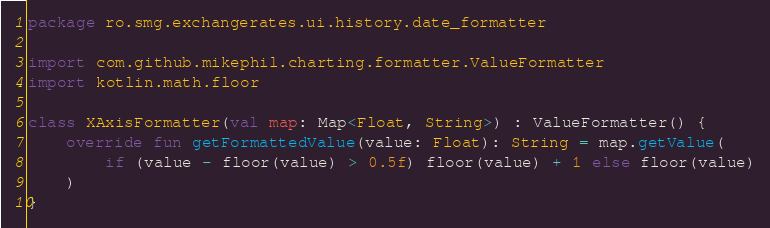<code> <loc_0><loc_0><loc_500><loc_500><_Kotlin_>package ro.smg.exchangerates.ui.history.date_formatter

import com.github.mikephil.charting.formatter.ValueFormatter
import kotlin.math.floor

class XAxisFormatter(val map: Map<Float, String>) : ValueFormatter() {
    override fun getFormattedValue(value: Float): String = map.getValue(
        if (value - floor(value) > 0.5f) floor(value) + 1 else floor(value)
    )
}</code> 